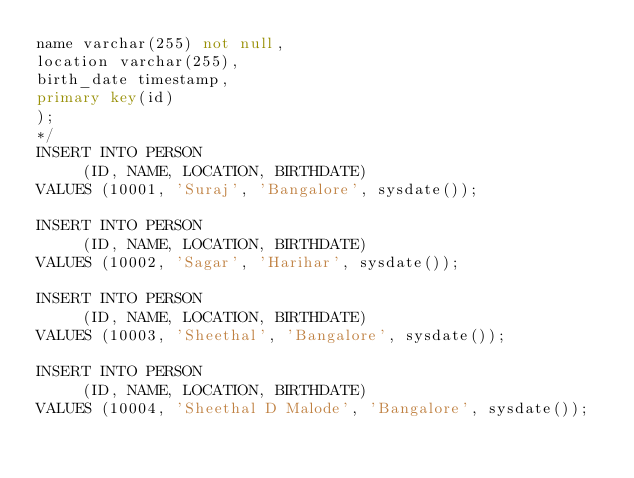Convert code to text. <code><loc_0><loc_0><loc_500><loc_500><_SQL_>name varchar(255) not null,
location varchar(255),
birth_date timestamp,
primary key(id)
);
*/
INSERT INTO PERSON 
     (ID, NAME, LOCATION, BIRTHDATE)
VALUES (10001, 'Suraj', 'Bangalore', sysdate());

INSERT INTO PERSON 
     (ID, NAME, LOCATION, BIRTHDATE)
VALUES (10002, 'Sagar', 'Harihar', sysdate());

INSERT INTO PERSON 
     (ID, NAME, LOCATION, BIRTHDATE)
VALUES (10003, 'Sheethal', 'Bangalore', sysdate());

INSERT INTO PERSON 
     (ID, NAME, LOCATION, BIRTHDATE)
VALUES (10004, 'Sheethal D Malode', 'Bangalore', sysdate());

</code> 